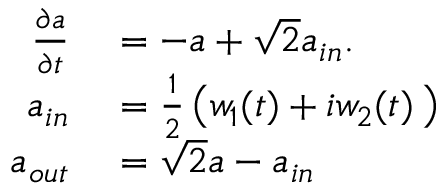<formula> <loc_0><loc_0><loc_500><loc_500>\begin{array} { r l } { \frac { \partial a } { \partial t } } & = - a + \sqrt { 2 } a _ { i n } . } \\ { a _ { i n } } & = \frac { 1 } { 2 } \left ( w _ { 1 } ( t ) + i w _ { 2 } ( t ) \, \right ) } \\ { a _ { o u t } } & = \sqrt { 2 } a - a _ { i n } } \end{array}</formula> 